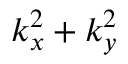Convert formula to latex. <formula><loc_0><loc_0><loc_500><loc_500>k _ { x } ^ { 2 } + k _ { y } ^ { 2 }</formula> 